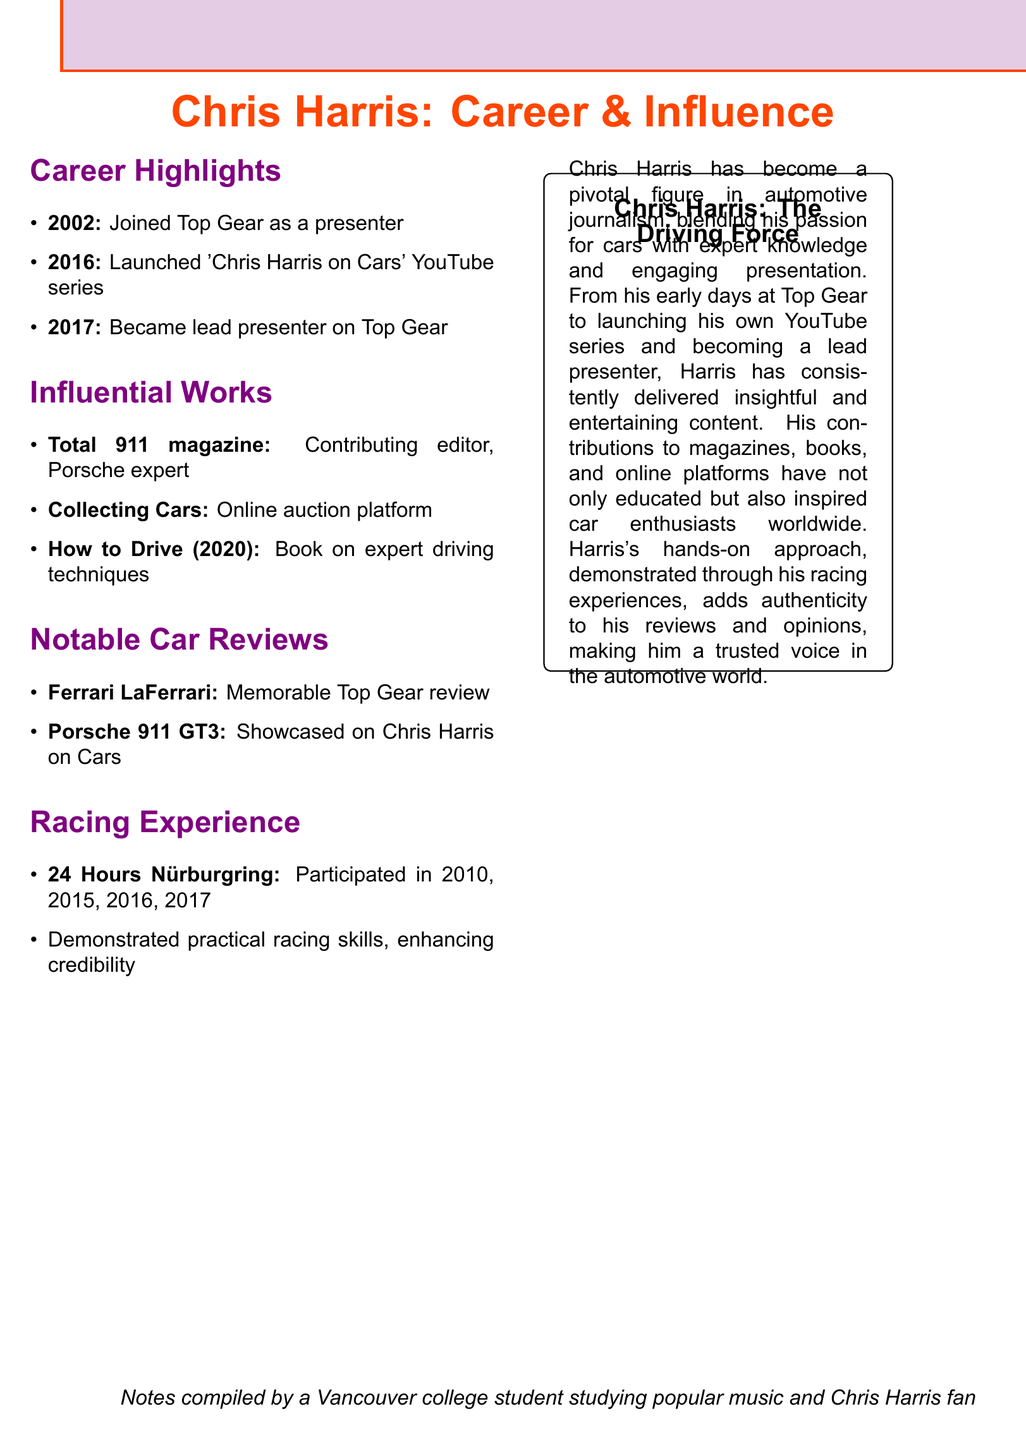What year did Chris Harris join Top Gear? The document states that Chris Harris joined Top Gear in the year 2002.
Answer: 2002 What is the title of Chris Harris's YouTube series? According to the notes, the title of his YouTube series is "Chris Harris on Cars."
Answer: Chris Harris on Cars In what year was "How to Drive" published? The document mentions that the book "How to Drive" was published in 2020.
Answer: 2020 What type of platform is "Collecting Cars"? The document describes "Collecting Cars" as an online auction platform.
Answer: Online auction platform How many times did Chris Harris participate in the 24 Hours Nürburgring? The document lists the years he participated as 2010, 2015, 2016, and 2017, totaling four events.
Answer: Four What impact did Chris Harris's racing experience have according to the document? The document states that his racing experience enhanced his credibility as a car reviewer.
Answer: Enhanced credibility Which car did Chris Harris review on Top Gear? The notes indicate that Chris Harris reviewed the Ferrari LaFerrari on Top Gear.
Answer: Ferrari LaFerrari What role did Chris Harris have in Total 911 magazine? He served as a contributing editor, establishing his expertise in Porsche vehicles.
Answer: Contributing editor What year did Chris Harris become the lead presenter on Top Gear? The document indicates that he became the lead presenter in 2017.
Answer: 2017 